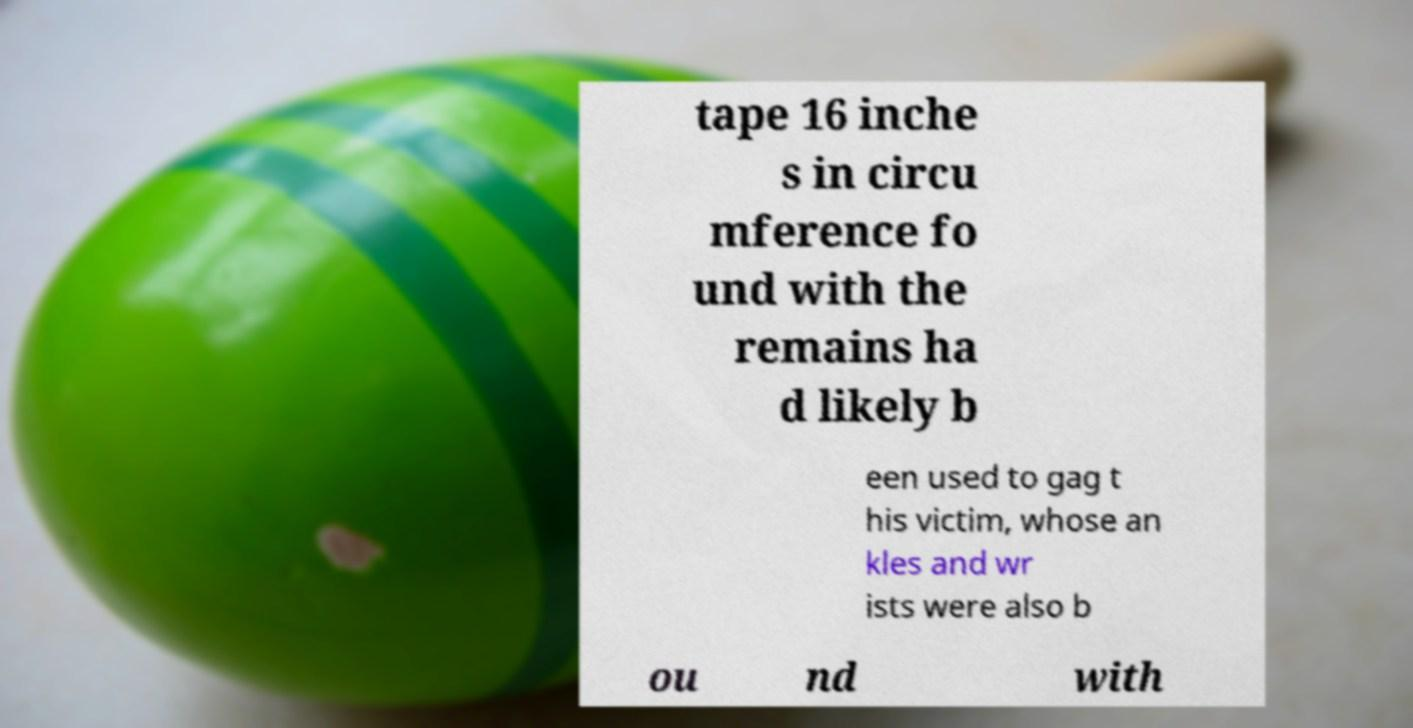What messages or text are displayed in this image? I need them in a readable, typed format. tape 16 inche s in circu mference fo und with the remains ha d likely b een used to gag t his victim, whose an kles and wr ists were also b ou nd with 